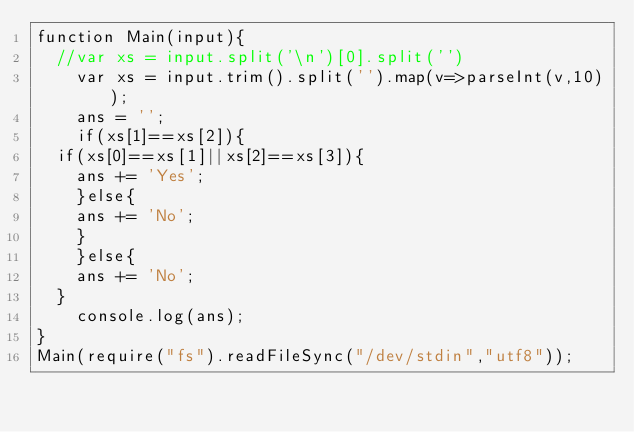<code> <loc_0><loc_0><loc_500><loc_500><_JavaScript_>function Main(input){
	//var xs = input.split('\n')[0].split('')
    var xs = input.trim().split('').map(v=>parseInt(v,10));
    ans = '';
    if(xs[1]==xs[2]){
	if(xs[0]==xs[1]||xs[2]==xs[3]){
    ans += 'Yes';
    }else{
    ans += 'No';
    }
    }else{
    ans += 'No';  
	}
    console.log(ans);
}
Main(require("fs").readFileSync("/dev/stdin","utf8"));</code> 